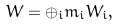Convert formula to latex. <formula><loc_0><loc_0><loc_500><loc_500>W = \oplus _ { i } m _ { i } W _ { i } ,</formula> 